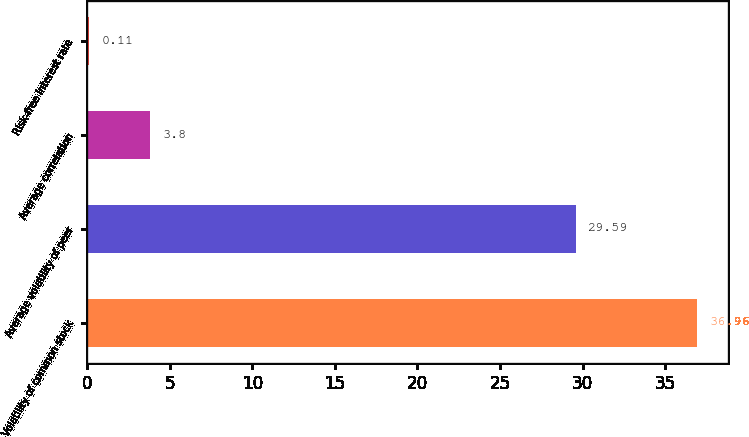Convert chart. <chart><loc_0><loc_0><loc_500><loc_500><bar_chart><fcel>Volatility of common stock<fcel>Average volatility of peer<fcel>Average correlation<fcel>Risk-free interest rate<nl><fcel>36.96<fcel>29.59<fcel>3.8<fcel>0.11<nl></chart> 